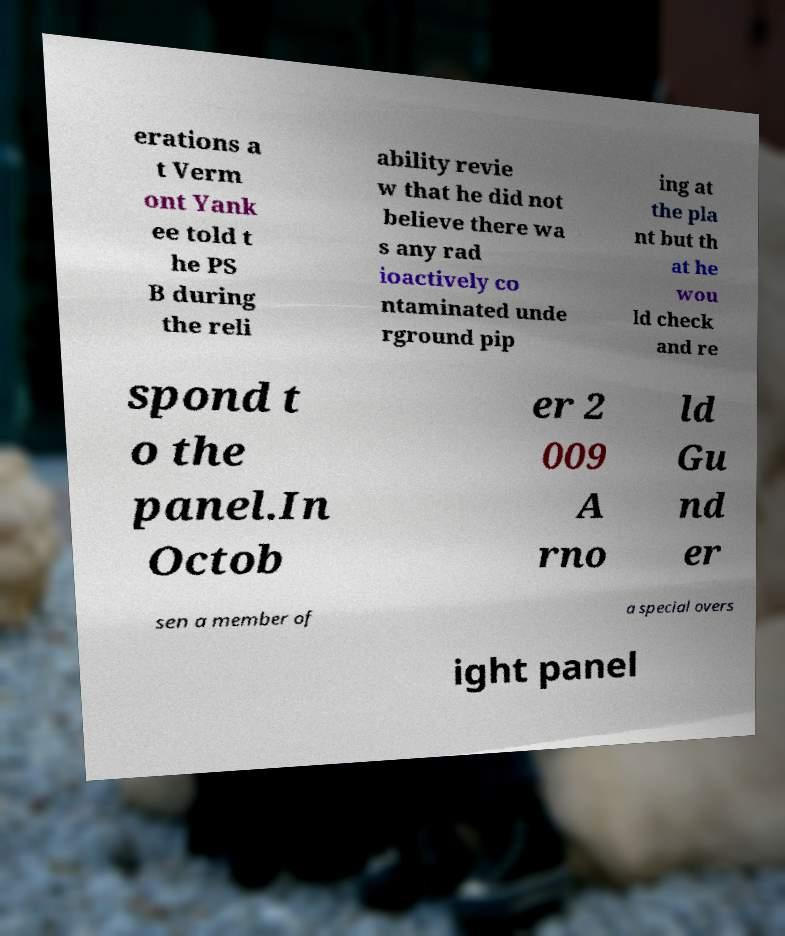Please read and relay the text visible in this image. What does it say? erations a t Verm ont Yank ee told t he PS B during the reli ability revie w that he did not believe there wa s any rad ioactively co ntaminated unde rground pip ing at the pla nt but th at he wou ld check and re spond t o the panel.In Octob er 2 009 A rno ld Gu nd er sen a member of a special overs ight panel 